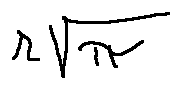Convert formula to latex. <formula><loc_0><loc_0><loc_500><loc_500>r \sqrt { \pi }</formula> 